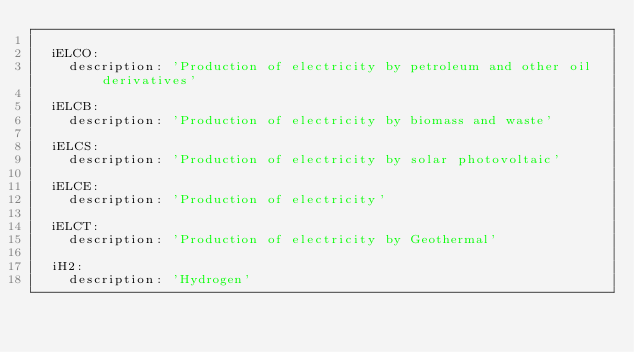Convert code to text. <code><loc_0><loc_0><loc_500><loc_500><_YAML_>
  iELCO:
    description: 'Production of electricity by petroleum and other oil derivatives'

  iELCB:
    description: 'Production of electricity by biomass and waste'

  iELCS:
    description: 'Production of electricity by solar photovoltaic'

  iELCE:
    description: 'Production of electricity'

  iELCT:
    description: 'Production of electricity by Geothermal'

  iH2:
    description: 'Hydrogen'
</code> 